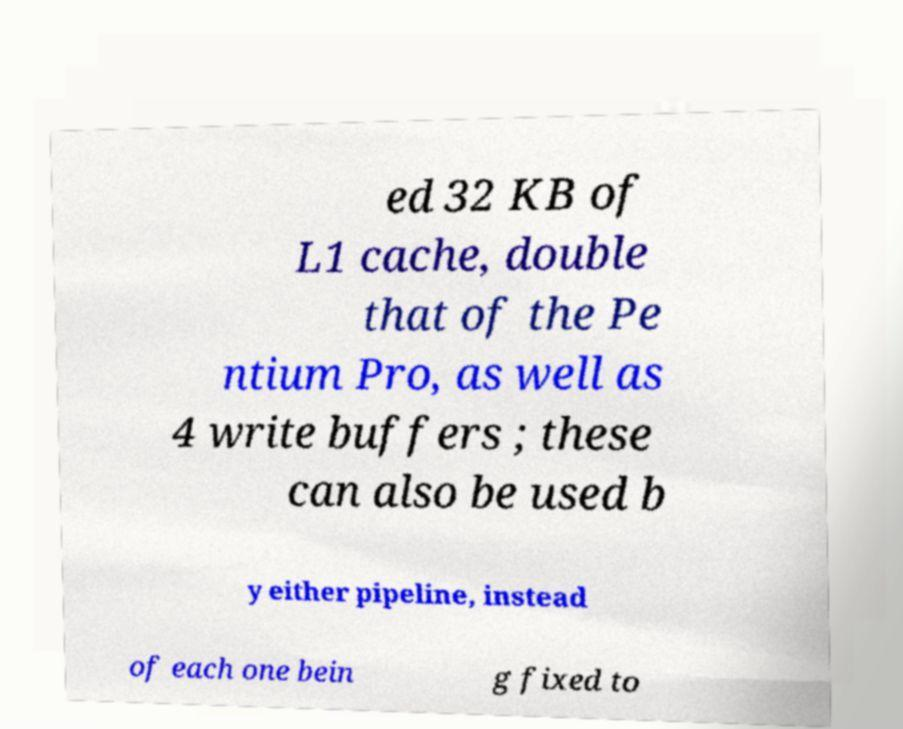I need the written content from this picture converted into text. Can you do that? ed 32 KB of L1 cache, double that of the Pe ntium Pro, as well as 4 write buffers ; these can also be used b y either pipeline, instead of each one bein g fixed to 